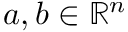Convert formula to latex. <formula><loc_0><loc_0><loc_500><loc_500>a , b \in \mathbb { R } ^ { n }</formula> 